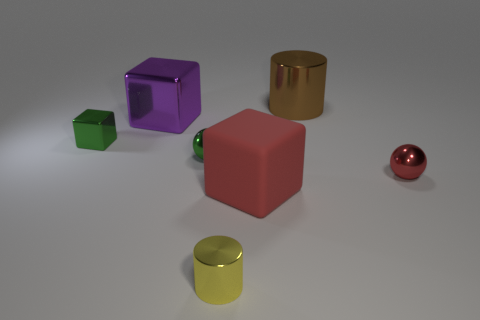Subtract all big purple metal blocks. How many blocks are left? 2 Add 1 yellow metallic cylinders. How many objects exist? 8 Subtract 1 blocks. How many blocks are left? 2 Subtract all cylinders. How many objects are left? 5 Add 3 green spheres. How many green spheres are left? 4 Add 1 small blue rubber spheres. How many small blue rubber spheres exist? 1 Subtract 0 blue cylinders. How many objects are left? 7 Subtract all large rubber spheres. Subtract all purple metal things. How many objects are left? 6 